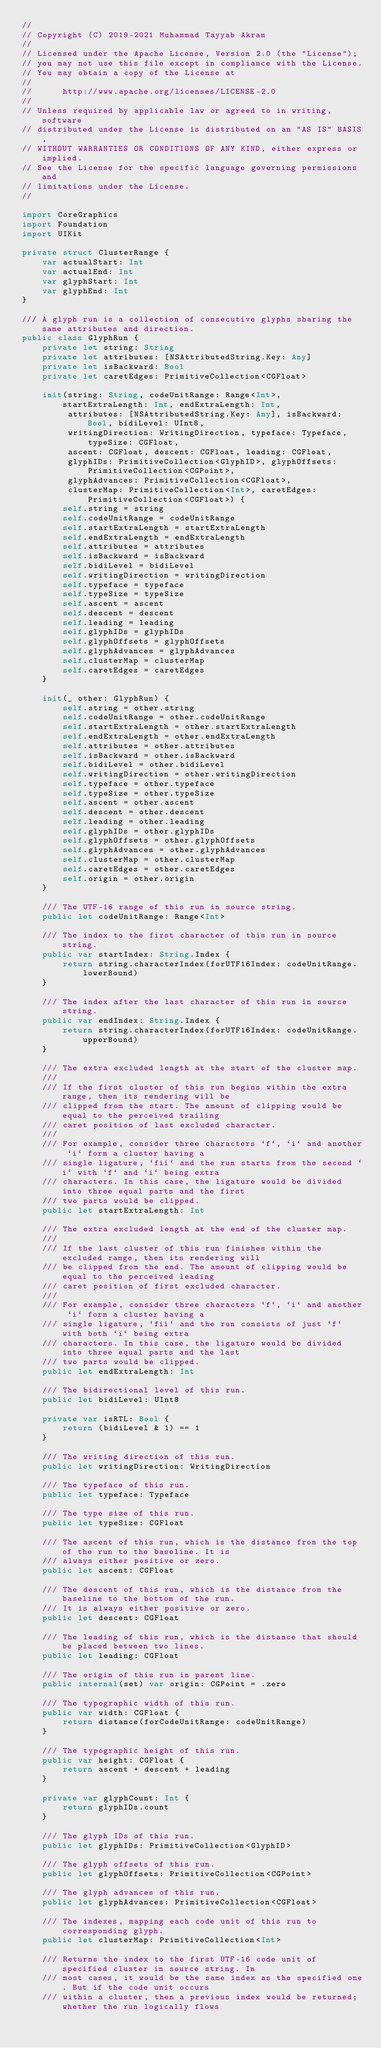<code> <loc_0><loc_0><loc_500><loc_500><_Swift_>//
// Copyright (C) 2019-2021 Muhammad Tayyab Akram
//
// Licensed under the Apache License, Version 2.0 (the "License");
// you may not use this file except in compliance with the License.
// You may obtain a copy of the License at
//
//      http://www.apache.org/licenses/LICENSE-2.0
//
// Unless required by applicable law or agreed to in writing, software
// distributed under the License is distributed on an "AS IS" BASIS,
// WITHOUT WARRANTIES OR CONDITIONS OF ANY KIND, either express or implied.
// See the License for the specific language governing permissions and
// limitations under the License.
//

import CoreGraphics
import Foundation
import UIKit

private struct ClusterRange {
    var actualStart: Int
    var actualEnd: Int
    var glyphStart: Int
    var glyphEnd: Int
}

/// A glyph run is a collection of consecutive glyphs sharing the same attributes and direction.
public class GlyphRun {
    private let string: String
    private let attributes: [NSAttributedString.Key: Any]
    private let isBackward: Bool
    private let caretEdges: PrimitiveCollection<CGFloat>

    init(string: String, codeUnitRange: Range<Int>, startExtraLength: Int, endExtraLength: Int,
         attributes: [NSAttributedString.Key: Any], isBackward: Bool, bidiLevel: UInt8,
         writingDirection: WritingDirection, typeface: Typeface, typeSize: CGFloat,
         ascent: CGFloat, descent: CGFloat, leading: CGFloat,
         glyphIDs: PrimitiveCollection<GlyphID>, glyphOffsets: PrimitiveCollection<CGPoint>,
         glyphAdvances: PrimitiveCollection<CGFloat>,
         clusterMap: PrimitiveCollection<Int>, caretEdges: PrimitiveCollection<CGFloat>) {
        self.string = string
        self.codeUnitRange = codeUnitRange
        self.startExtraLength = startExtraLength
        self.endExtraLength = endExtraLength
        self.attributes = attributes
        self.isBackward = isBackward
        self.bidiLevel = bidiLevel
        self.writingDirection = writingDirection
        self.typeface = typeface
        self.typeSize = typeSize
        self.ascent = ascent
        self.descent = descent
        self.leading = leading
        self.glyphIDs = glyphIDs
        self.glyphOffsets = glyphOffsets
        self.glyphAdvances = glyphAdvances
        self.clusterMap = clusterMap
        self.caretEdges = caretEdges
    }

    init(_ other: GlyphRun) {
        self.string = other.string
        self.codeUnitRange = other.codeUnitRange
        self.startExtraLength = other.startExtraLength
        self.endExtraLength = other.endExtraLength
        self.attributes = other.attributes
        self.isBackward = other.isBackward
        self.bidiLevel = other.bidiLevel
        self.writingDirection = other.writingDirection
        self.typeface = other.typeface
        self.typeSize = other.typeSize
        self.ascent = other.ascent
        self.descent = other.descent
        self.leading = other.leading
        self.glyphIDs = other.glyphIDs
        self.glyphOffsets = other.glyphOffsets
        self.glyphAdvances = other.glyphAdvances
        self.clusterMap = other.clusterMap
        self.caretEdges = other.caretEdges
        self.origin = other.origin
    }

    /// The UTF-16 range of this run in source string.
    public let codeUnitRange: Range<Int>

    /// The index to the first character of this run in source string.
    public var startIndex: String.Index {
        return string.characterIndex(forUTF16Index: codeUnitRange.lowerBound)
    }

    /// The index after the last character of this run in source string.
    public var endIndex: String.Index {
        return string.characterIndex(forUTF16Index: codeUnitRange.upperBound)
    }

    /// The extra excluded length at the start of the cluster map.
    ///
    /// If the first cluster of this run begins within the extra range, then its rendering will be
    /// clipped from the start. The amount of clipping would be equal to the perceived trailing
    /// caret position of last excluded character.
    ///
    /// For example, consider three characters `f`, `i` and another `i` form a cluster having a
    /// single ligature, `fii` and the run starts from the second `i` with `f` and `i` being extra
    /// characters. In this case, the ligature would be divided into three equal parts and the first
    /// two parts would be clipped.
    public let startExtraLength: Int

    /// The extra excluded length at the end of the cluster map.
    ///
    /// If the last cluster of this run finishes within the excluded range, then its rendering will
    /// be clipped from the end. The amount of clipping would be equal to the perceived leading
    /// caret position of first excluded character.
    ///
    /// For example, consider three characters `f`, `i` and another `i` form a cluster having a
    /// single ligature, `fii` and the run consists of just `f` with both `i` being extra
    /// characters. In this case, the ligature would be divided into three equal parts and the last
    /// two parts would be clipped.
    public let endExtraLength: Int

    /// The bidirectional level of this run.
    public let bidiLevel: UInt8

    private var isRTL: Bool {
        return (bidiLevel & 1) == 1
    }

    /// The writing direction of this run.
    public let writingDirection: WritingDirection

    /// The typeface of this run.
    public let typeface: Typeface

    /// The type size of this run.
    public let typeSize: CGFloat

    /// The ascent of this run, which is the distance from the top of the run to the baseline. It is
    /// always either positive or zero.
    public let ascent: CGFloat

    /// The descent of this run, which is the distance from the baseline to the bottom of the run.
    /// It is always either positive or zero.
    public let descent: CGFloat

    /// The leading of this run, which is the distance that should be placed between two lines.
    public let leading: CGFloat

    /// The origin of this run in parent line.
    public internal(set) var origin: CGPoint = .zero

    /// The typographic width of this run.
    public var width: CGFloat {
        return distance(forCodeUnitRange: codeUnitRange)
    }

    /// The typographic height of this run.
    public var height: CGFloat {
        return ascent + descent + leading
    }

    private var glyphCount: Int {
        return glyphIDs.count
    }

    /// The glyph IDs of this run.
    public let glyphIDs: PrimitiveCollection<GlyphID>

    /// The glyph offsets of this run.
    public let glyphOffsets: PrimitiveCollection<CGPoint>

    /// The glyph advances of this run.
    public let glyphAdvances: PrimitiveCollection<CGFloat>

    /// The indexes, mapping each code unit of this run to corresponding glyph.
    public let clusterMap: PrimitiveCollection<Int>

    /// Returns the index to the first UTF-16 code unit of specified cluster in source string. In
    /// most cases, it would be the same index as the specified one. But if the code unit occurs
    /// within a cluster, then a previous index would be returned; whether the run logically flows</code> 